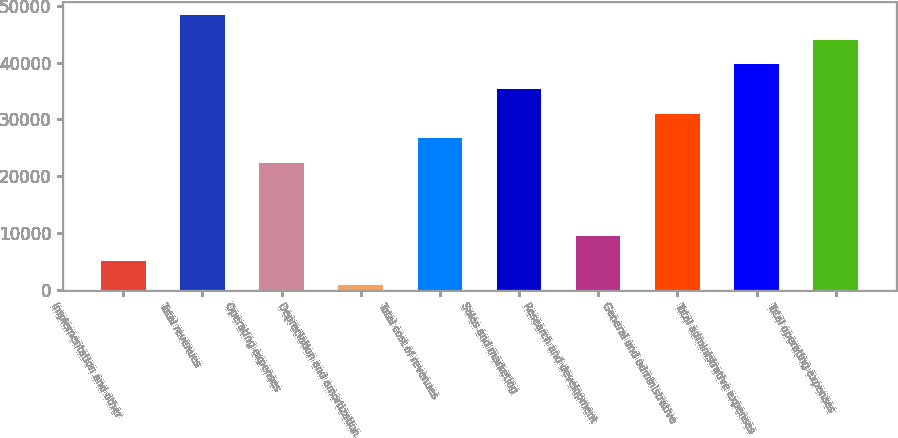<chart> <loc_0><loc_0><loc_500><loc_500><bar_chart><fcel>Implementation and other<fcel>Total revenues<fcel>Operating expenses<fcel>Depreciation and amortization<fcel>Total cost of revenues<fcel>Sales and marketing<fcel>Research and development<fcel>General and administrative<fcel>Total administrative expenses<fcel>Total operating expenses<nl><fcel>5077.2<fcel>48369.2<fcel>22394<fcel>748<fcel>26723.2<fcel>35381.6<fcel>9406.4<fcel>31052.4<fcel>39710.8<fcel>44040<nl></chart> 